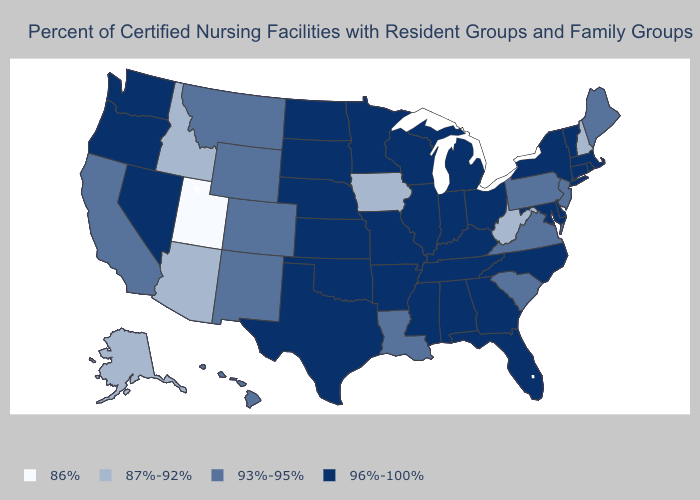Name the states that have a value in the range 93%-95%?
Write a very short answer. California, Colorado, Hawaii, Louisiana, Maine, Montana, New Jersey, New Mexico, Pennsylvania, South Carolina, Virginia, Wyoming. Which states have the highest value in the USA?
Answer briefly. Alabama, Arkansas, Connecticut, Delaware, Florida, Georgia, Illinois, Indiana, Kansas, Kentucky, Maryland, Massachusetts, Michigan, Minnesota, Mississippi, Missouri, Nebraska, Nevada, New York, North Carolina, North Dakota, Ohio, Oklahoma, Oregon, Rhode Island, South Dakota, Tennessee, Texas, Vermont, Washington, Wisconsin. What is the lowest value in the USA?
Short answer required. 86%. Which states have the lowest value in the USA?
Give a very brief answer. Utah. Name the states that have a value in the range 86%?
Be succinct. Utah. How many symbols are there in the legend?
Short answer required. 4. What is the highest value in the USA?
Keep it brief. 96%-100%. Does Mississippi have a lower value than Georgia?
Give a very brief answer. No. Name the states that have a value in the range 93%-95%?
Short answer required. California, Colorado, Hawaii, Louisiana, Maine, Montana, New Jersey, New Mexico, Pennsylvania, South Carolina, Virginia, Wyoming. Does Montana have the highest value in the USA?
Answer briefly. No. How many symbols are there in the legend?
Concise answer only. 4. Does Mississippi have a lower value than Kansas?
Concise answer only. No. Among the states that border Nebraska , does Wyoming have the lowest value?
Quick response, please. No. Does Idaho have the highest value in the USA?
Answer briefly. No. Name the states that have a value in the range 96%-100%?
Write a very short answer. Alabama, Arkansas, Connecticut, Delaware, Florida, Georgia, Illinois, Indiana, Kansas, Kentucky, Maryland, Massachusetts, Michigan, Minnesota, Mississippi, Missouri, Nebraska, Nevada, New York, North Carolina, North Dakota, Ohio, Oklahoma, Oregon, Rhode Island, South Dakota, Tennessee, Texas, Vermont, Washington, Wisconsin. 